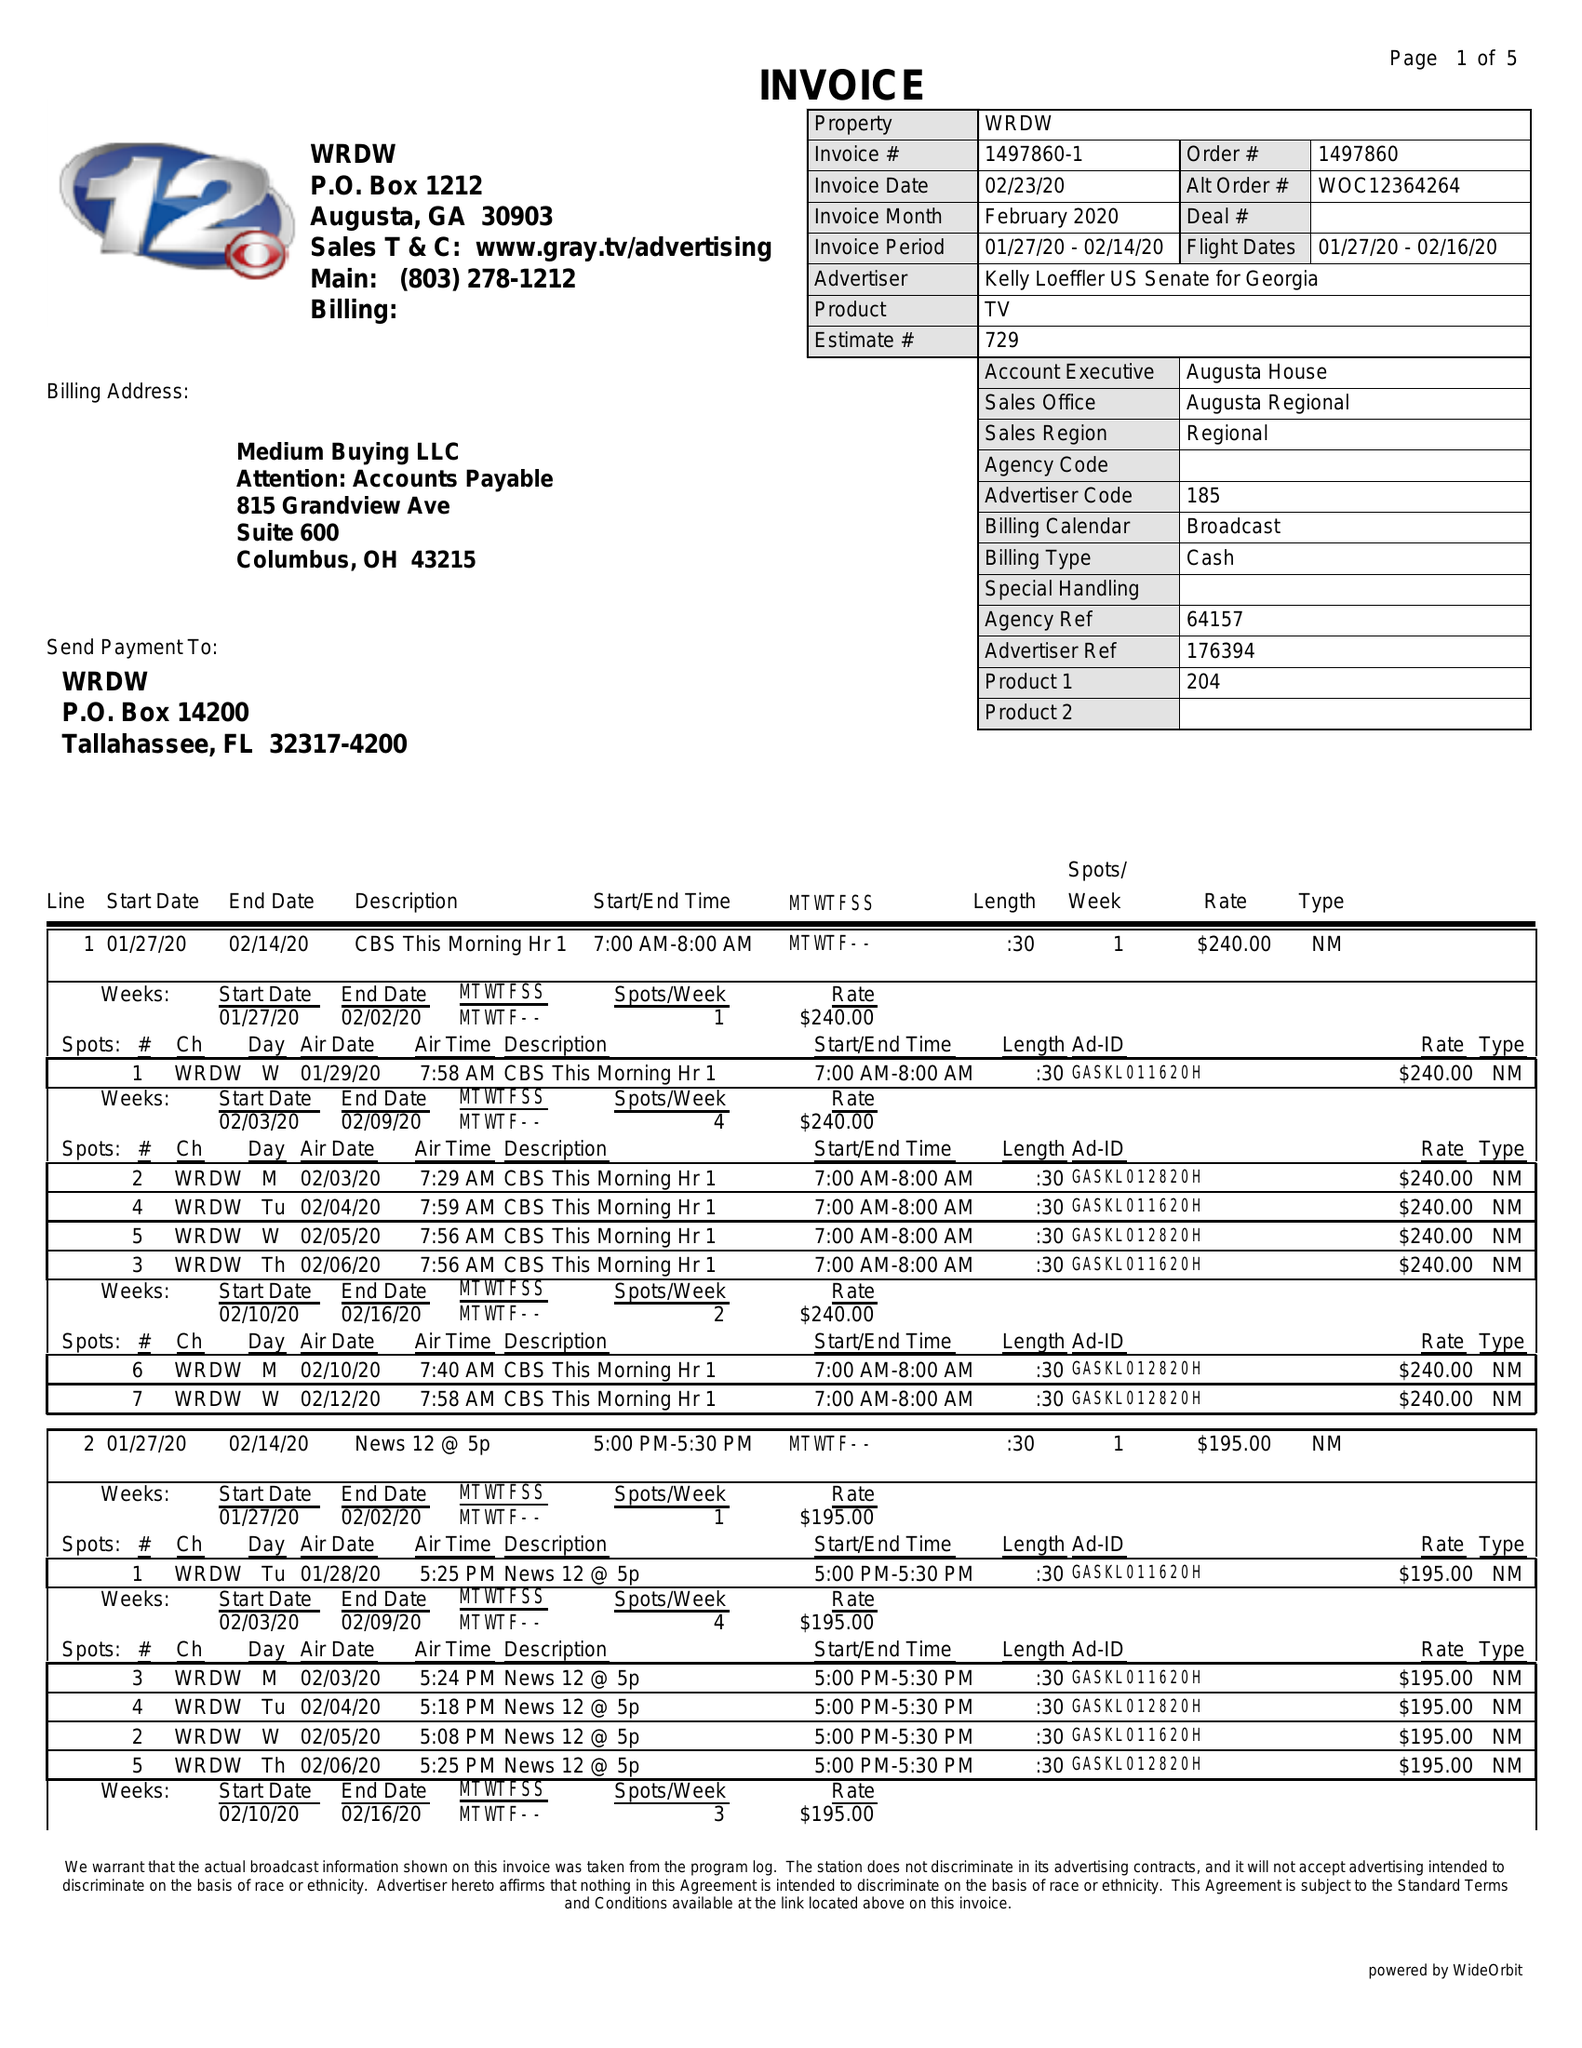What is the value for the flight_to?
Answer the question using a single word or phrase. 02/16/20 